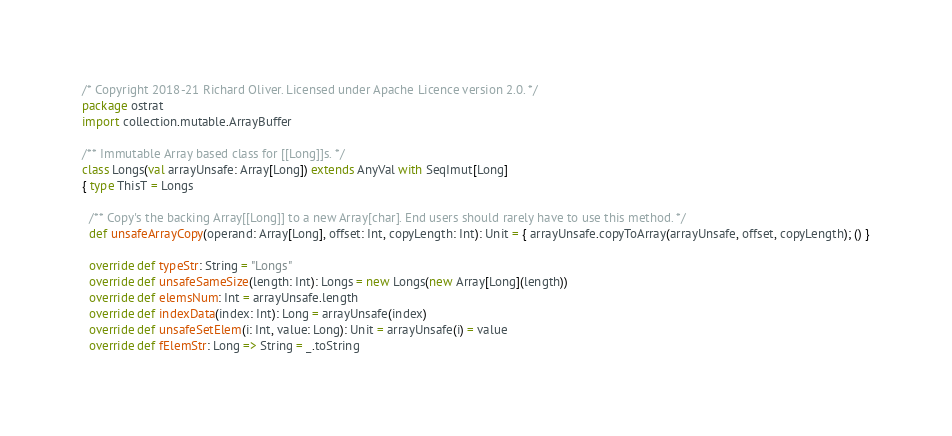Convert code to text. <code><loc_0><loc_0><loc_500><loc_500><_Scala_>/* Copyright 2018-21 Richard Oliver. Licensed under Apache Licence version 2.0. */
package ostrat
import collection.mutable.ArrayBuffer

/** Immutable Array based class for [[Long]]s. */
class Longs(val arrayUnsafe: Array[Long]) extends AnyVal with SeqImut[Long]
{ type ThisT = Longs

  /** Copy's the backing Array[[Long]] to a new Array[char]. End users should rarely have to use this method. */
  def unsafeArrayCopy(operand: Array[Long], offset: Int, copyLength: Int): Unit = { arrayUnsafe.copyToArray(arrayUnsafe, offset, copyLength); () }

  override def typeStr: String = "Longs"
  override def unsafeSameSize(length: Int): Longs = new Longs(new Array[Long](length))
  override def elemsNum: Int = arrayUnsafe.length
  override def indexData(index: Int): Long = arrayUnsafe(index)
  override def unsafeSetElem(i: Int, value: Long): Unit = arrayUnsafe(i) = value
  override def fElemStr: Long => String = _.toString
</code> 